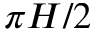Convert formula to latex. <formula><loc_0><loc_0><loc_500><loc_500>\pi H / 2</formula> 